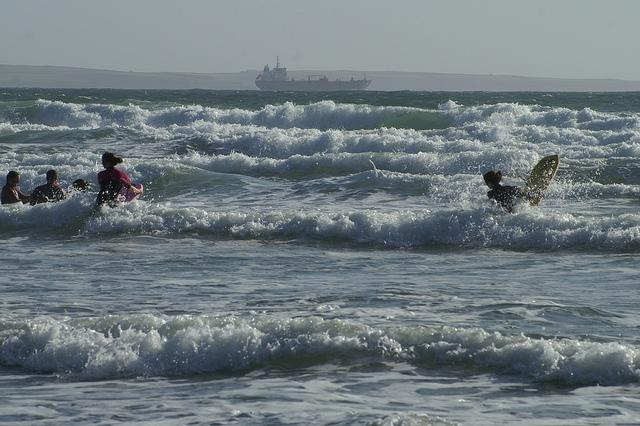What activity is taking place besides surfing?

Choices:
A) fishing
B) paddling
C) swimming
D) canoeing swimming 